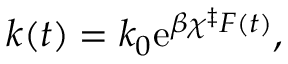<formula> <loc_0><loc_0><loc_500><loc_500>k ( t ) = k _ { 0 } e ^ { \beta \chi ^ { \ddag } F ( t ) } ,</formula> 